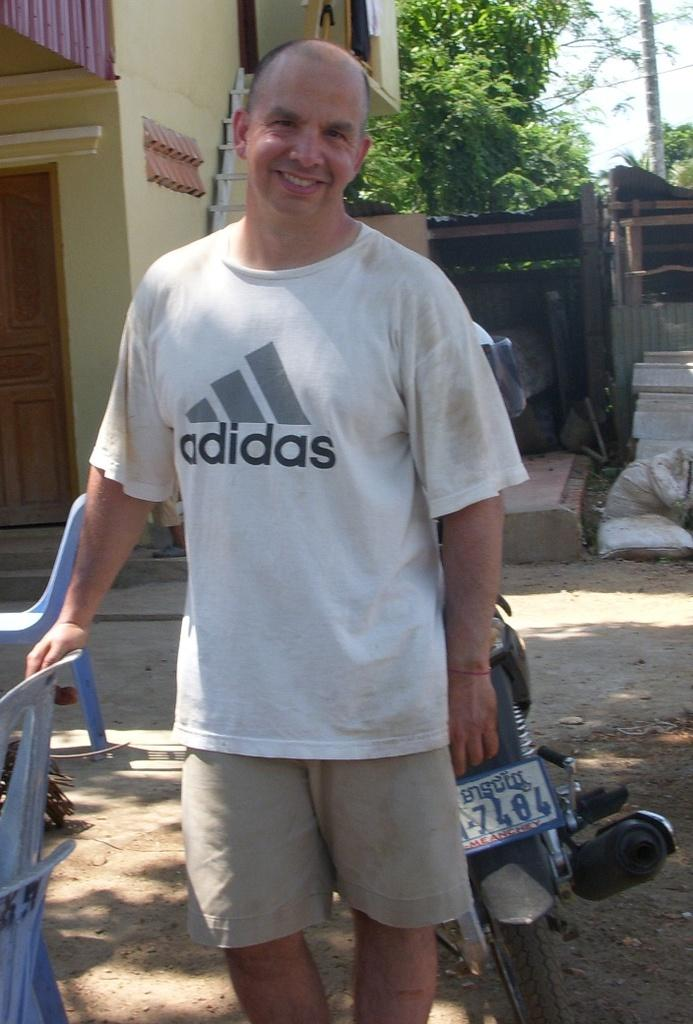What is the person in the image wearing? The person is wearing a white t-shirt and shorts. What can be seen on the left side of the image? There are chairs on the left side of the image. What vehicle is present in the image? There is a motorcycle in the image. What is visible in the background of the image? There is a building and trees in the background of the image. What type of ant can be seen crawling on the person's white t-shirt in the image? There are no ants present in the image, and therefore no such activity can be observed. 